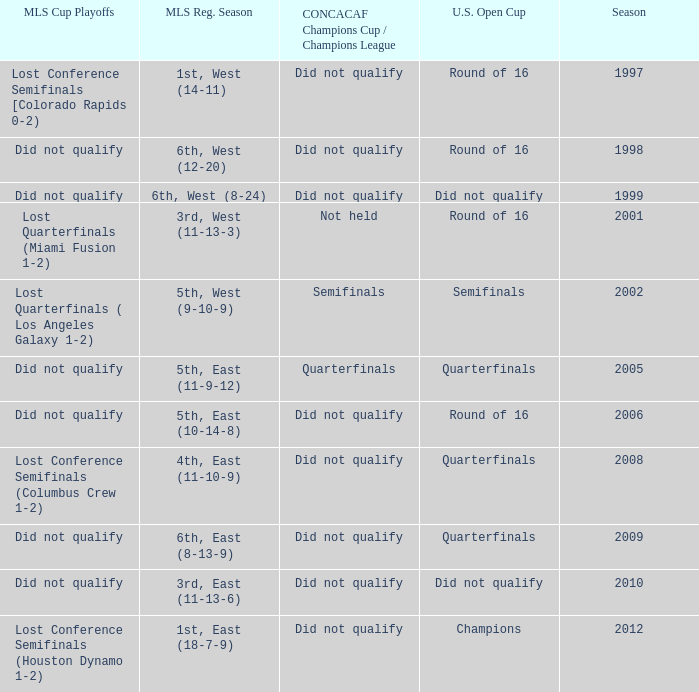Could you parse the entire table as a dict? {'header': ['MLS Cup Playoffs', 'MLS Reg. Season', 'CONCACAF Champions Cup / Champions League', 'U.S. Open Cup', 'Season'], 'rows': [['Lost Conference Semifinals [Colorado Rapids 0-2)', '1st, West (14-11)', 'Did not qualify', 'Round of 16', '1997'], ['Did not qualify', '6th, West (12-20)', 'Did not qualify', 'Round of 16', '1998'], ['Did not qualify', '6th, West (8-24)', 'Did not qualify', 'Did not qualify', '1999'], ['Lost Quarterfinals (Miami Fusion 1-2)', '3rd, West (11-13-3)', 'Not held', 'Round of 16', '2001'], ['Lost Quarterfinals ( Los Angeles Galaxy 1-2)', '5th, West (9-10-9)', 'Semifinals', 'Semifinals', '2002'], ['Did not qualify', '5th, East (11-9-12)', 'Quarterfinals', 'Quarterfinals', '2005'], ['Did not qualify', '5th, East (10-14-8)', 'Did not qualify', 'Round of 16', '2006'], ['Lost Conference Semifinals (Columbus Crew 1-2)', '4th, East (11-10-9)', 'Did not qualify', 'Quarterfinals', '2008'], ['Did not qualify', '6th, East (8-13-9)', 'Did not qualify', 'Quarterfinals', '2009'], ['Did not qualify', '3rd, East (11-13-6)', 'Did not qualify', 'Did not qualify', '2010'], ['Lost Conference Semifinals (Houston Dynamo 1-2)', '1st, East (18-7-9)', 'Did not qualify', 'Champions', '2012']]} What were the placements of the team in regular season when they reached quarterfinals in the U.S. Open Cup but did not qualify for the Concaf Champions Cup? 4th, East (11-10-9), 6th, East (8-13-9). 